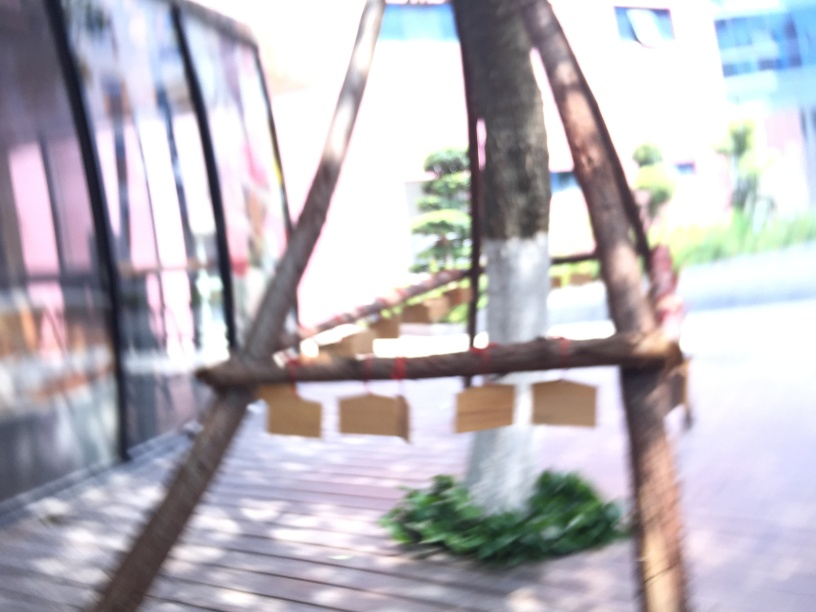How does the overexposure affect the image?
A. dark and sharp appearance
B. vibrant and clear appearance
C. colorful and balanced appearance
D. bright and hazy appearance
Answer with the option's letter from the given choices directly.
 D. 